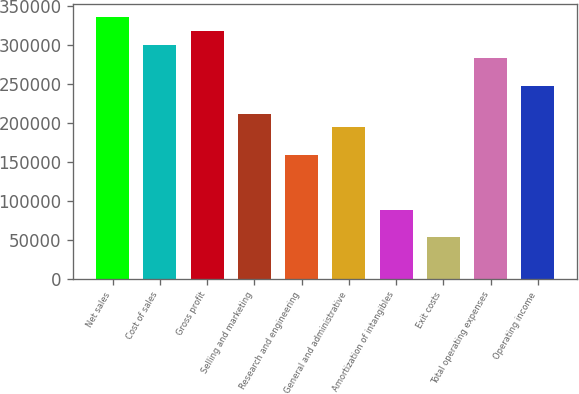<chart> <loc_0><loc_0><loc_500><loc_500><bar_chart><fcel>Net sales<fcel>Cost of sales<fcel>Gross profit<fcel>Selling and marketing<fcel>Research and engineering<fcel>General and administrative<fcel>Amortization of intangibles<fcel>Exit costs<fcel>Total operating expenses<fcel>Operating income<nl><fcel>335566<fcel>300243<fcel>317905<fcel>211937<fcel>158953<fcel>194275<fcel>88307.2<fcel>52984.4<fcel>282582<fcel>247259<nl></chart> 